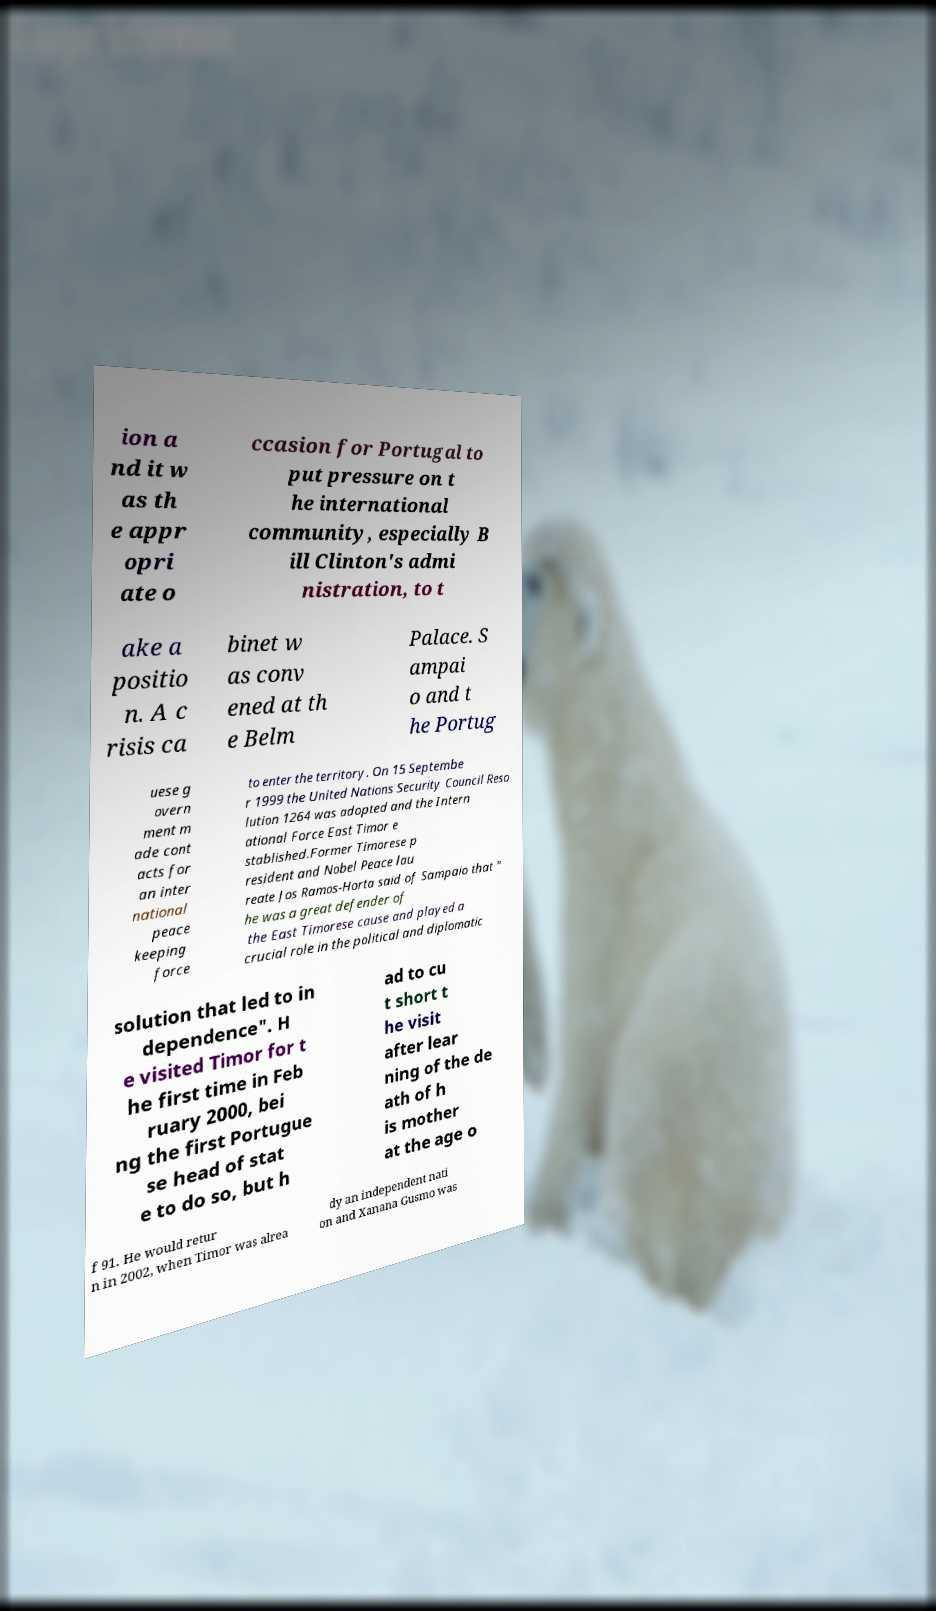Can you accurately transcribe the text from the provided image for me? ion a nd it w as th e appr opri ate o ccasion for Portugal to put pressure on t he international community, especially B ill Clinton's admi nistration, to t ake a positio n. A c risis ca binet w as conv ened at th e Belm Palace. S ampai o and t he Portug uese g overn ment m ade cont acts for an inter national peace keeping force to enter the territory. On 15 Septembe r 1999 the United Nations Security Council Reso lution 1264 was adopted and the Intern ational Force East Timor e stablished.Former Timorese p resident and Nobel Peace lau reate Jos Ramos-Horta said of Sampaio that " he was a great defender of the East Timorese cause and played a crucial role in the political and diplomatic solution that led to in dependence". H e visited Timor for t he first time in Feb ruary 2000, bei ng the first Portugue se head of stat e to do so, but h ad to cu t short t he visit after lear ning of the de ath of h is mother at the age o f 91. He would retur n in 2002, when Timor was alrea dy an independent nati on and Xanana Gusmo was 